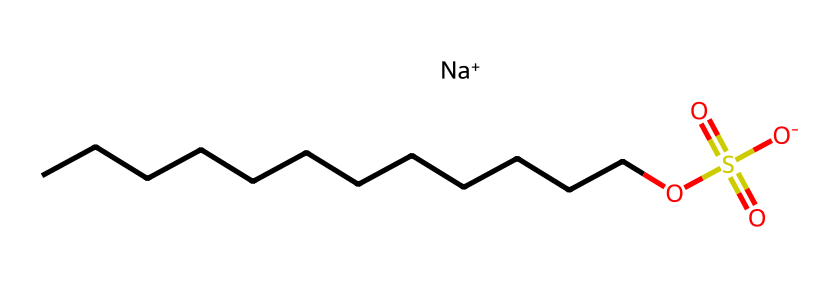What is the common name of the compound represented by this structure? The SMILES notation contains the element "Na" and the dodecyl (C12) hydrocarbon chain, indicating this is a sodium salt of dodecyl sulfate. The common name for this surfactant is sodium dodecyl sulfate.
Answer: sodium dodecyl sulfate How many carbon atoms are present in the structure? The structure shows a long hydrocarbon chain denoted by the sequence of "CCCCCCCCCCCC" in the SMILES representation, which indicates there are 12 carbon atoms (C12).
Answer: 12 What functional groups are present in sodium dodecyl sulfate? The presence of "OS(=O)(=O)[O-]" indicates a sulfate functional group, which is characteristic of surfactants. Additionally, there is a long alkyl chain (the hydrocarbon part). Therefore, the primary functional group is sulfate, with an alkyl chain.
Answer: sulfate How many total oxygen atoms are there in the molecule? The sulfate group is represented by "OS(=O)(=O)[O-]", which consists of 4 oxygen atoms in total (1 from -O and 3 from the sulfate structure). Therefore, the total number of oxygen atoms in sodium dodecyl sulfate is 4.
Answer: 4 What is the charge of the sodium ion in this compound? The SMILES includes "[Na+]", indicating that the sodium ion carries a positive charge. This is typical for ionic compounds where the sodium ion balances the negative charge of the surfate group.
Answer: positive Is sodium dodecyl sulfate hydrophilic or hydrophobic? The presence of the sulfate group makes this compound hydrophilic since sulfate is polar and interacts well with water, while the long hydrocarbon chain renders the compound amphiphilic.
Answer: hydrophilic What type of surfactant is sodium dodecyl sulfate? Sodium dodecyl sulfate has a negative charge due to the sulfate moiety, categorizing it as an anionic surfactant. Anionic surfactants have negatively charged head groups, which is characteristic of this structure.
Answer: anionic 